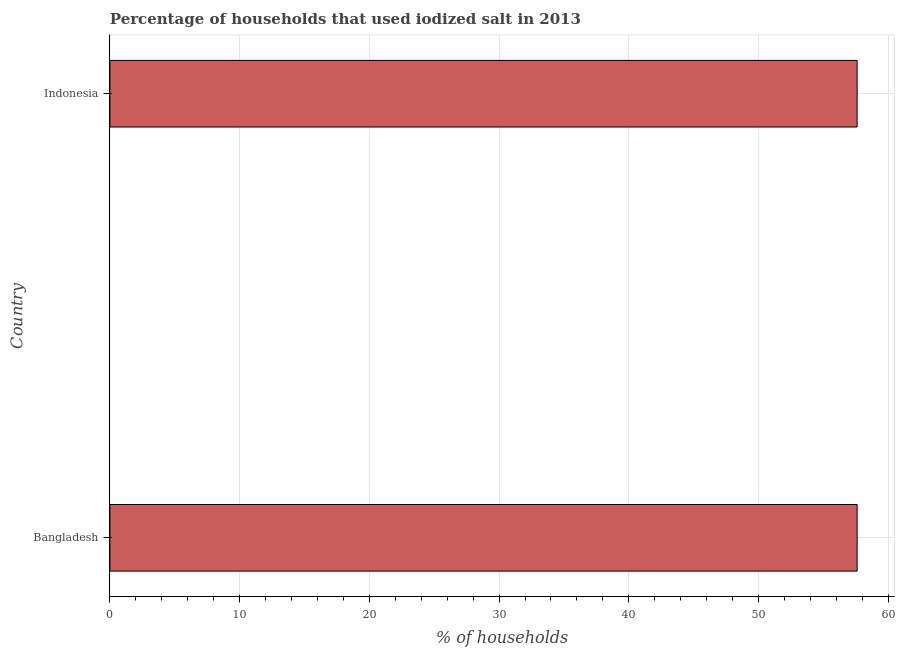Does the graph contain any zero values?
Provide a short and direct response. No. What is the title of the graph?
Offer a terse response. Percentage of households that used iodized salt in 2013. What is the label or title of the X-axis?
Your answer should be compact. % of households. What is the percentage of households where iodized salt is consumed in Bangladesh?
Your answer should be compact. 57.6. Across all countries, what is the maximum percentage of households where iodized salt is consumed?
Ensure brevity in your answer.  57.6. Across all countries, what is the minimum percentage of households where iodized salt is consumed?
Your answer should be very brief. 57.6. In which country was the percentage of households where iodized salt is consumed minimum?
Your answer should be compact. Bangladesh. What is the sum of the percentage of households where iodized salt is consumed?
Provide a succinct answer. 115.2. What is the difference between the percentage of households where iodized salt is consumed in Bangladesh and Indonesia?
Keep it short and to the point. 0. What is the average percentage of households where iodized salt is consumed per country?
Provide a short and direct response. 57.6. What is the median percentage of households where iodized salt is consumed?
Provide a short and direct response. 57.6. In how many countries, is the percentage of households where iodized salt is consumed greater than 44 %?
Your answer should be compact. 2. In how many countries, is the percentage of households where iodized salt is consumed greater than the average percentage of households where iodized salt is consumed taken over all countries?
Your answer should be very brief. 0. What is the difference between two consecutive major ticks on the X-axis?
Your response must be concise. 10. Are the values on the major ticks of X-axis written in scientific E-notation?
Your answer should be compact. No. What is the % of households of Bangladesh?
Offer a terse response. 57.6. What is the % of households in Indonesia?
Offer a terse response. 57.6. What is the difference between the % of households in Bangladesh and Indonesia?
Offer a very short reply. 0. What is the ratio of the % of households in Bangladesh to that in Indonesia?
Offer a very short reply. 1. 